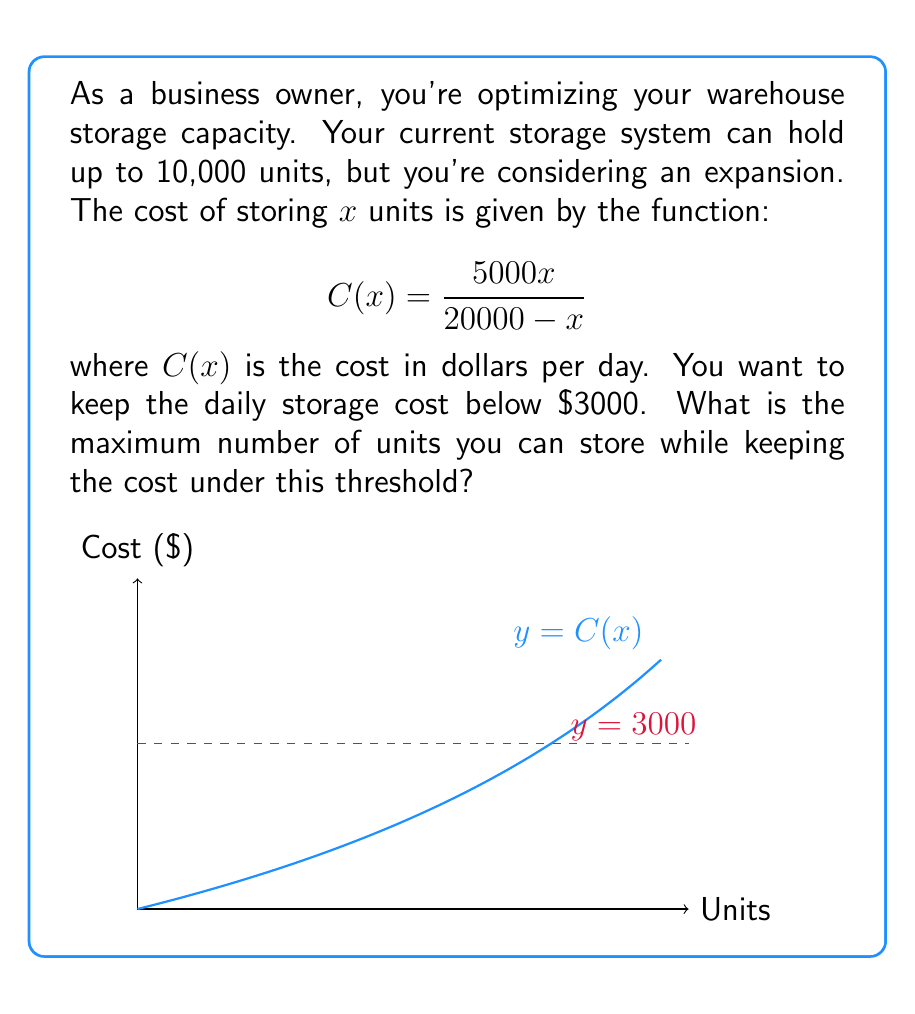Provide a solution to this math problem. Let's approach this step-by-step:

1) We need to solve the inequality:

   $$\frac{5000x}{20000 - x} < 3000$$

2) Multiply both sides by $(20000 - x)$:

   $$5000x < 3000(20000 - x)$$

3) Distribute on the right side:

   $$5000x < 60000000 - 3000x$$

4) Add $3000x$ to both sides:

   $$8000x < 60000000$$

5) Divide both sides by 8000:

   $$x < 7500$$

6) Since x represents the number of units, it must be a whole number. Therefore, the maximum number of units is 7499.

7) We can verify:
   
   $$C(7499) = \frac{5000(7499)}{20000 - 7499} \approx 2999.60$$

   Which is indeed less than $3000.
Answer: 7499 units 